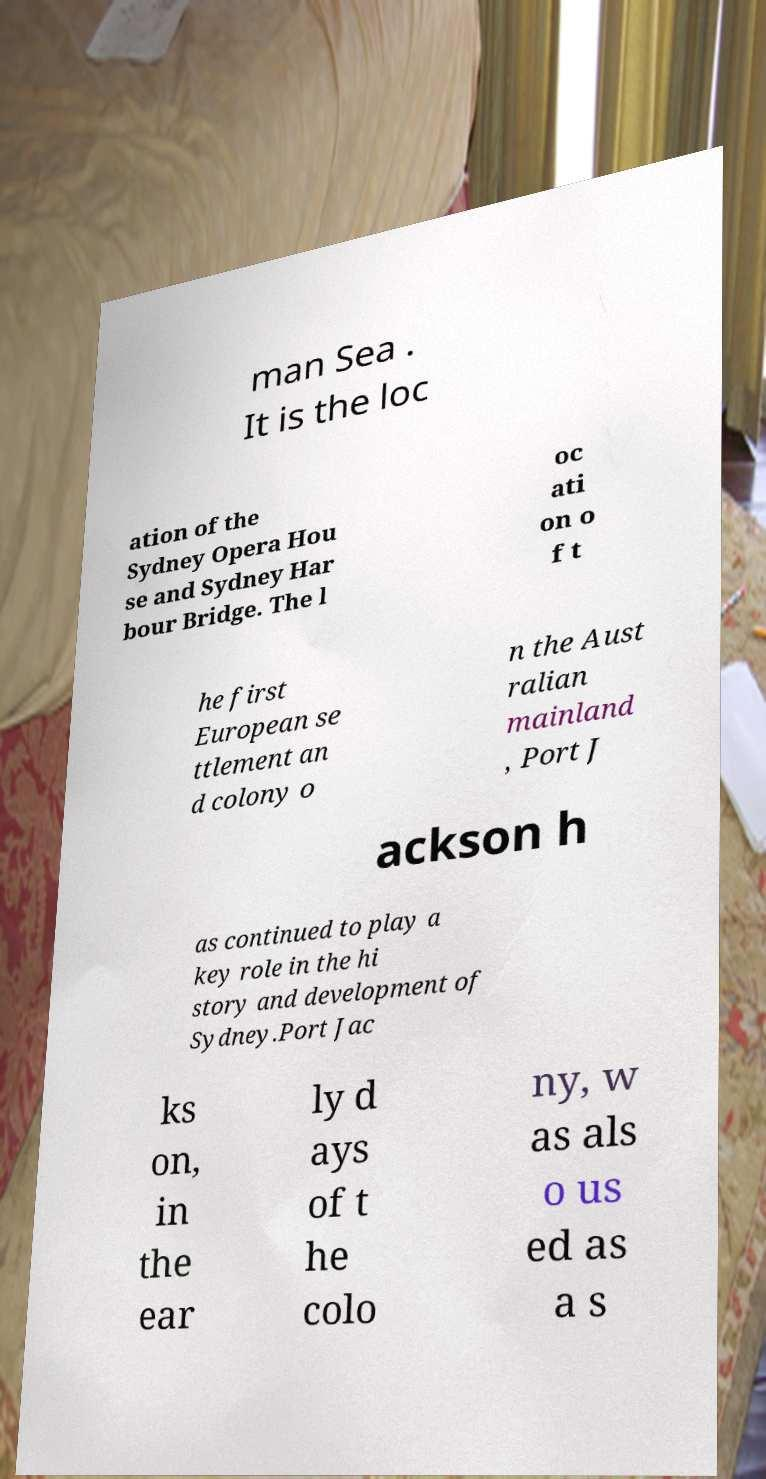Could you extract and type out the text from this image? man Sea . It is the loc ation of the Sydney Opera Hou se and Sydney Har bour Bridge. The l oc ati on o f t he first European se ttlement an d colony o n the Aust ralian mainland , Port J ackson h as continued to play a key role in the hi story and development of Sydney.Port Jac ks on, in the ear ly d ays of t he colo ny, w as als o us ed as a s 